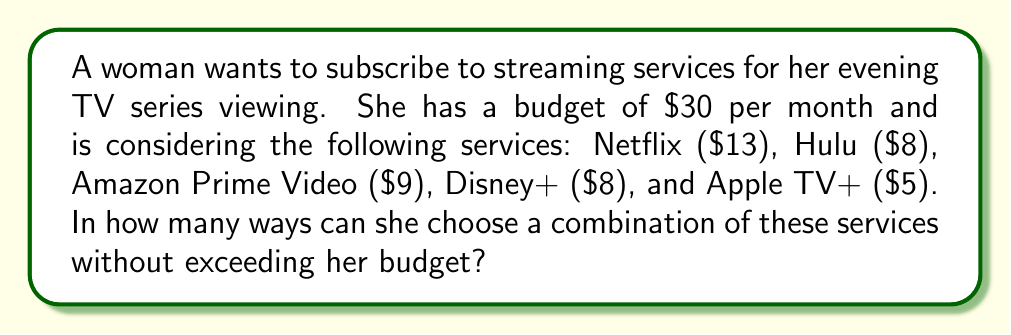Can you solve this math problem? Let's approach this step-by-step:

1) First, we need to list all possible combinations of services that fit within the $30 budget.

2) We can use the combinations formula to calculate this. Let's denote each service as follows:
   N: Netflix, H: Hulu, A: Amazon Prime Video, D: Disney+, T: Apple TV+

3) Possible combinations:
   - Single services: N, H, A, D, T (5 ways)
   - Two services: NH, NA, ND, NT, HA, HD, HT, AD, AT, DT (10 ways)
   - Three services: NHT, HAT, HDT (3 ways)

4) Let's verify each combination:
   - NH: $13 + $8 = $21
   - NA: $13 + $9 = $22
   - ND: $13 + $8 = $21
   - NT: $13 + $5 = $18
   - HA: $8 + $9 = $17
   - HD: $8 + $8 = $16
   - HT: $8 + $5 = $13
   - AD: $9 + $8 = $17
   - AT: $9 + $5 = $14
   - DT: $8 + $5 = $13
   - NHT: $13 + $8 + $5 = $26
   - HAT: $8 + $9 + $5 = $22
   - HDT: $8 + $8 + $5 = $21

5) The total number of ways is the sum of all these combinations:
   $$5 + 10 + 3 = 18$$

Therefore, there are 18 ways to choose a combination of these services without exceeding the $30 budget.
Answer: 18 ways 